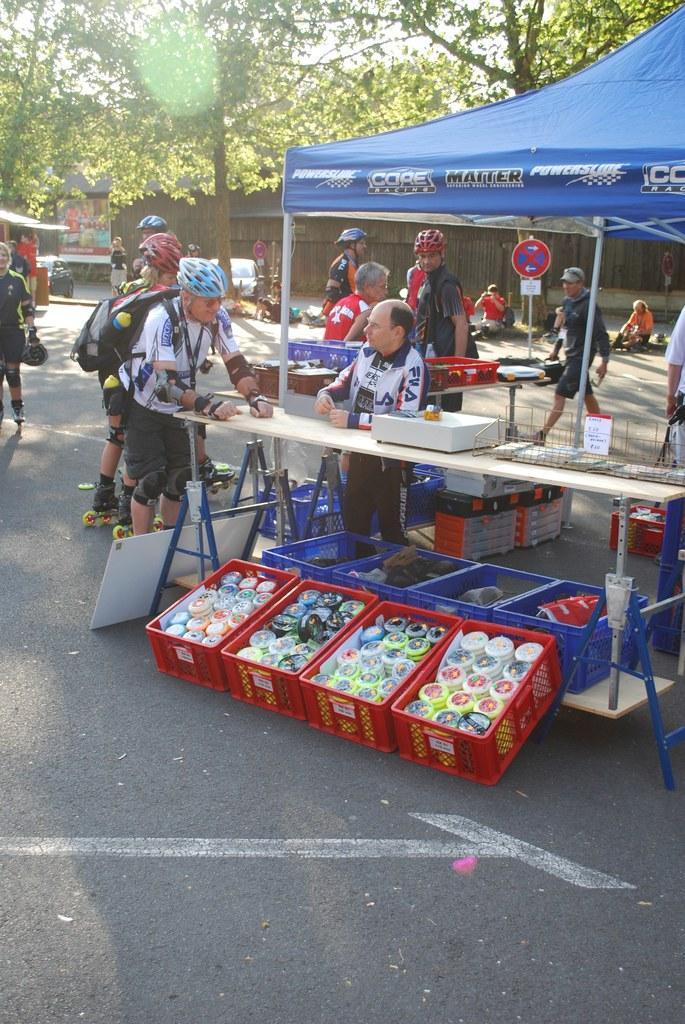How would you summarize this image in a sentence or two? In this picture we can see a tent, on the right side we can see trays and a table, there are some boxes present on these trays, we can see some things on the table, there are some people in the middle, some of them wore helmets and skates, in the background we can see trees, signboards and a hoarding, we can also see some people are sitting in the background. 